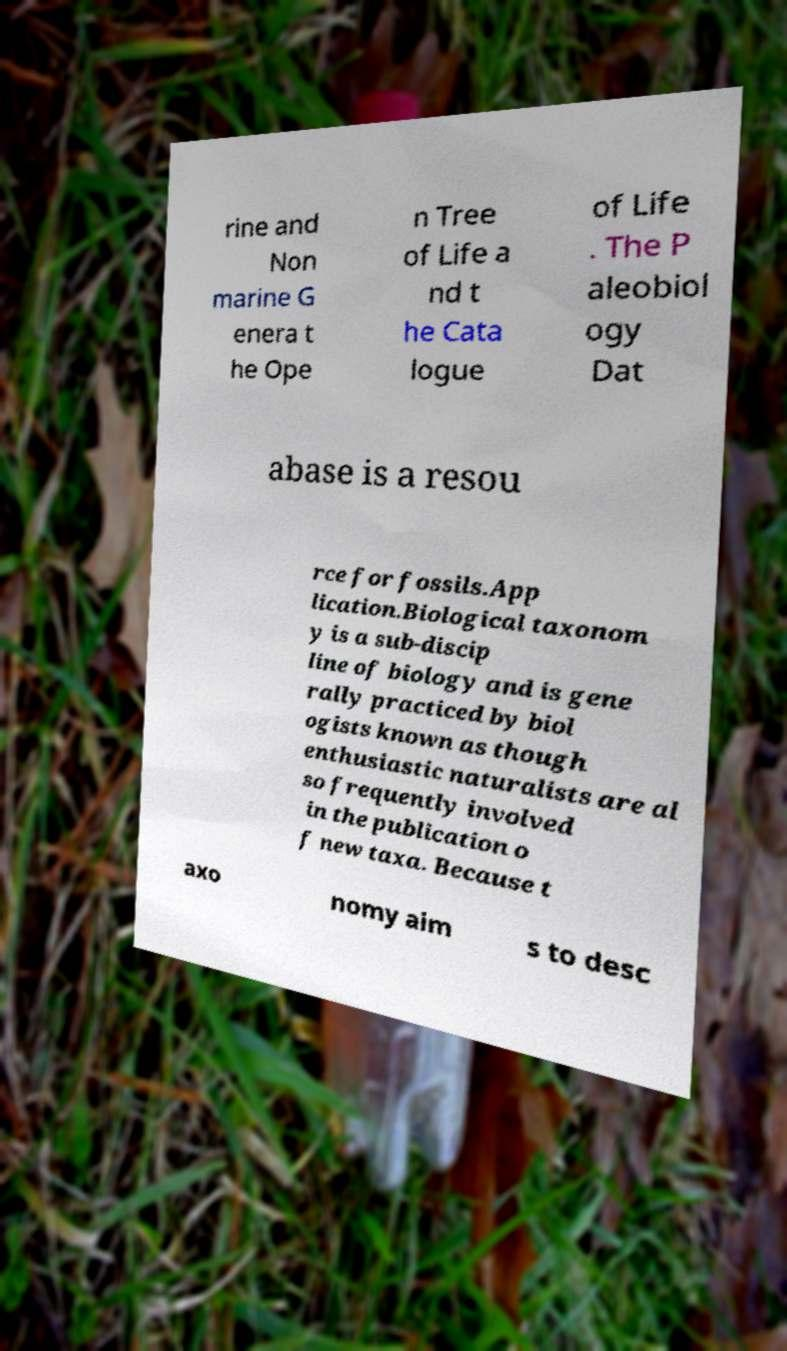What messages or text are displayed in this image? I need them in a readable, typed format. rine and Non marine G enera t he Ope n Tree of Life a nd t he Cata logue of Life . The P aleobiol ogy Dat abase is a resou rce for fossils.App lication.Biological taxonom y is a sub-discip line of biology and is gene rally practiced by biol ogists known as though enthusiastic naturalists are al so frequently involved in the publication o f new taxa. Because t axo nomy aim s to desc 